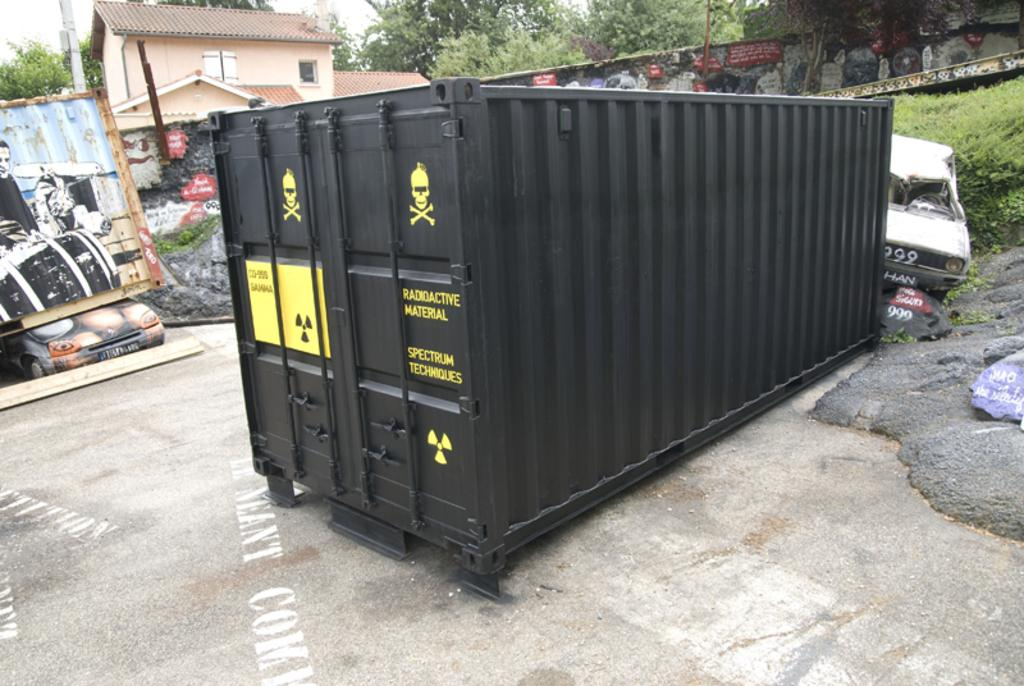What is the main object in the image? There is a container in the image. What else can be seen in the image besides the container? There is a vehicle, plants, trees, houses, a board, a wall, and poles in the image. What is the background of the image? The sky is visible in the background of the image. What type of club can be seen in the image? There is no club present in the image. Can you tell me how many toes are visible in the image? There are no toes visible in the image. 